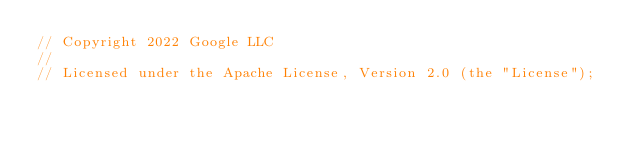Convert code to text. <code><loc_0><loc_0><loc_500><loc_500><_C#_>// Copyright 2022 Google LLC
//
// Licensed under the Apache License, Version 2.0 (the "License");</code> 